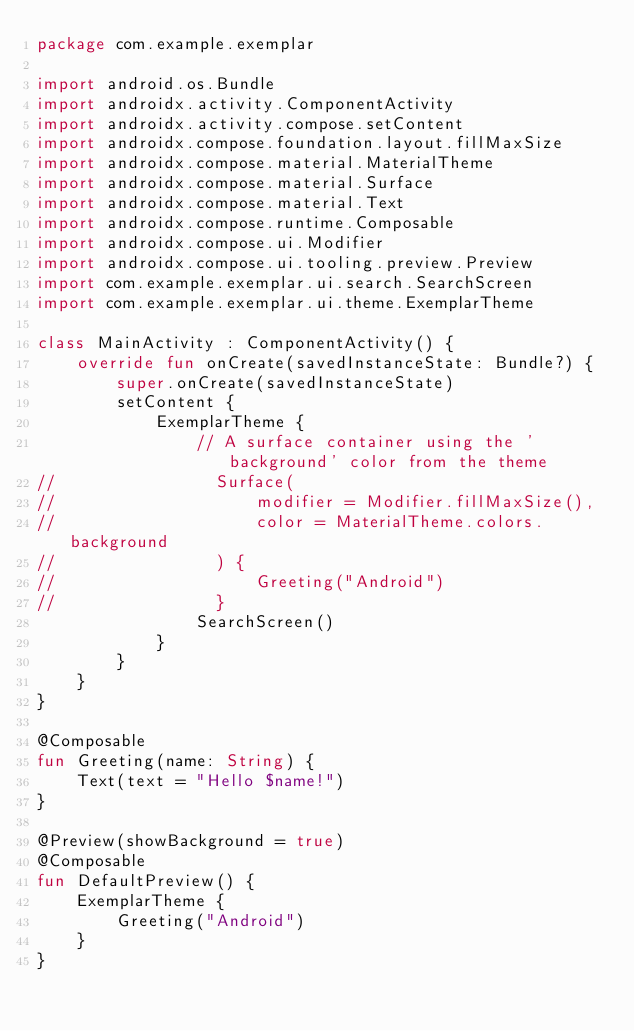Convert code to text. <code><loc_0><loc_0><loc_500><loc_500><_Kotlin_>package com.example.exemplar

import android.os.Bundle
import androidx.activity.ComponentActivity
import androidx.activity.compose.setContent
import androidx.compose.foundation.layout.fillMaxSize
import androidx.compose.material.MaterialTheme
import androidx.compose.material.Surface
import androidx.compose.material.Text
import androidx.compose.runtime.Composable
import androidx.compose.ui.Modifier
import androidx.compose.ui.tooling.preview.Preview
import com.example.exemplar.ui.search.SearchScreen
import com.example.exemplar.ui.theme.ExemplarTheme

class MainActivity : ComponentActivity() {
    override fun onCreate(savedInstanceState: Bundle?) {
        super.onCreate(savedInstanceState)
        setContent {
            ExemplarTheme {
                // A surface container using the 'background' color from the theme
//                Surface(
//                    modifier = Modifier.fillMaxSize(),
//                    color = MaterialTheme.colors.background
//                ) {
//                    Greeting("Android")
//                }
                SearchScreen()
            }
        }
    }
}

@Composable
fun Greeting(name: String) {
    Text(text = "Hello $name!")
}

@Preview(showBackground = true)
@Composable
fun DefaultPreview() {
    ExemplarTheme {
        Greeting("Android")
    }
}</code> 